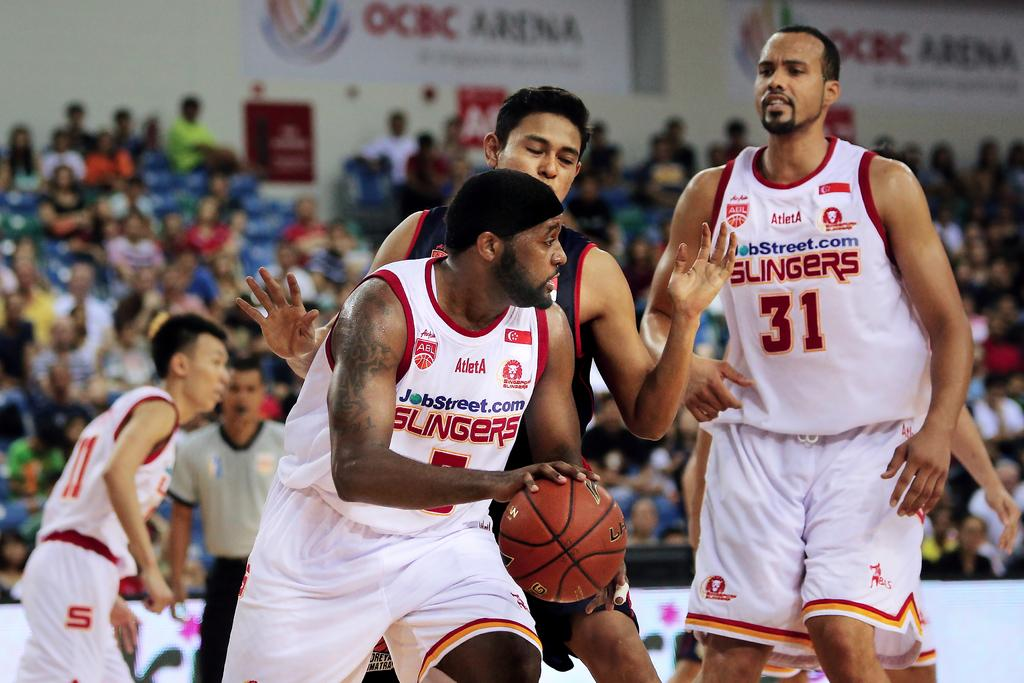Provide a one-sentence caption for the provided image. basketball players with one wearing the number 31 jersy. 